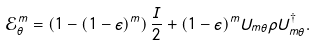<formula> <loc_0><loc_0><loc_500><loc_500>\mathcal { E } _ { \theta } ^ { m } = \left ( 1 - ( 1 - \epsilon ) ^ { m } \right ) \frac { I } { 2 } + ( 1 - \epsilon ) ^ { m } U _ { m \theta } \rho U _ { m \theta } ^ { \dagger } .</formula> 